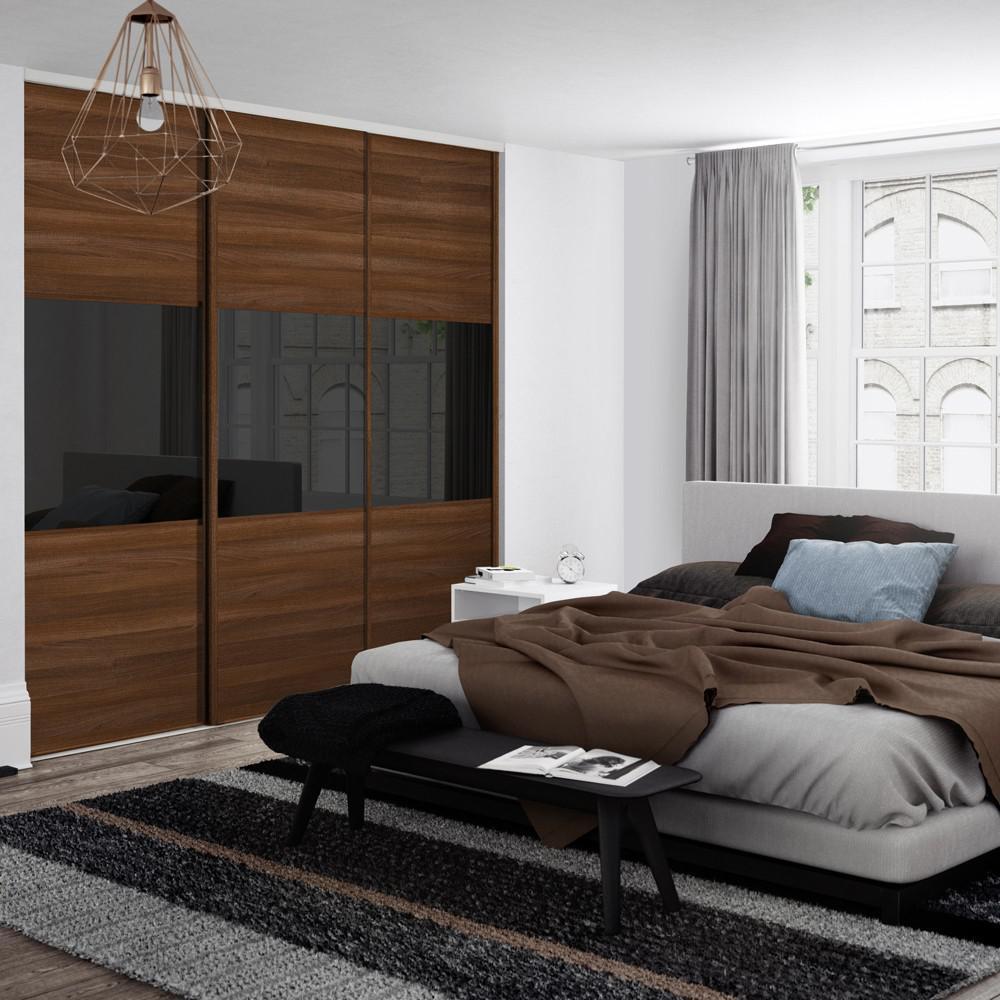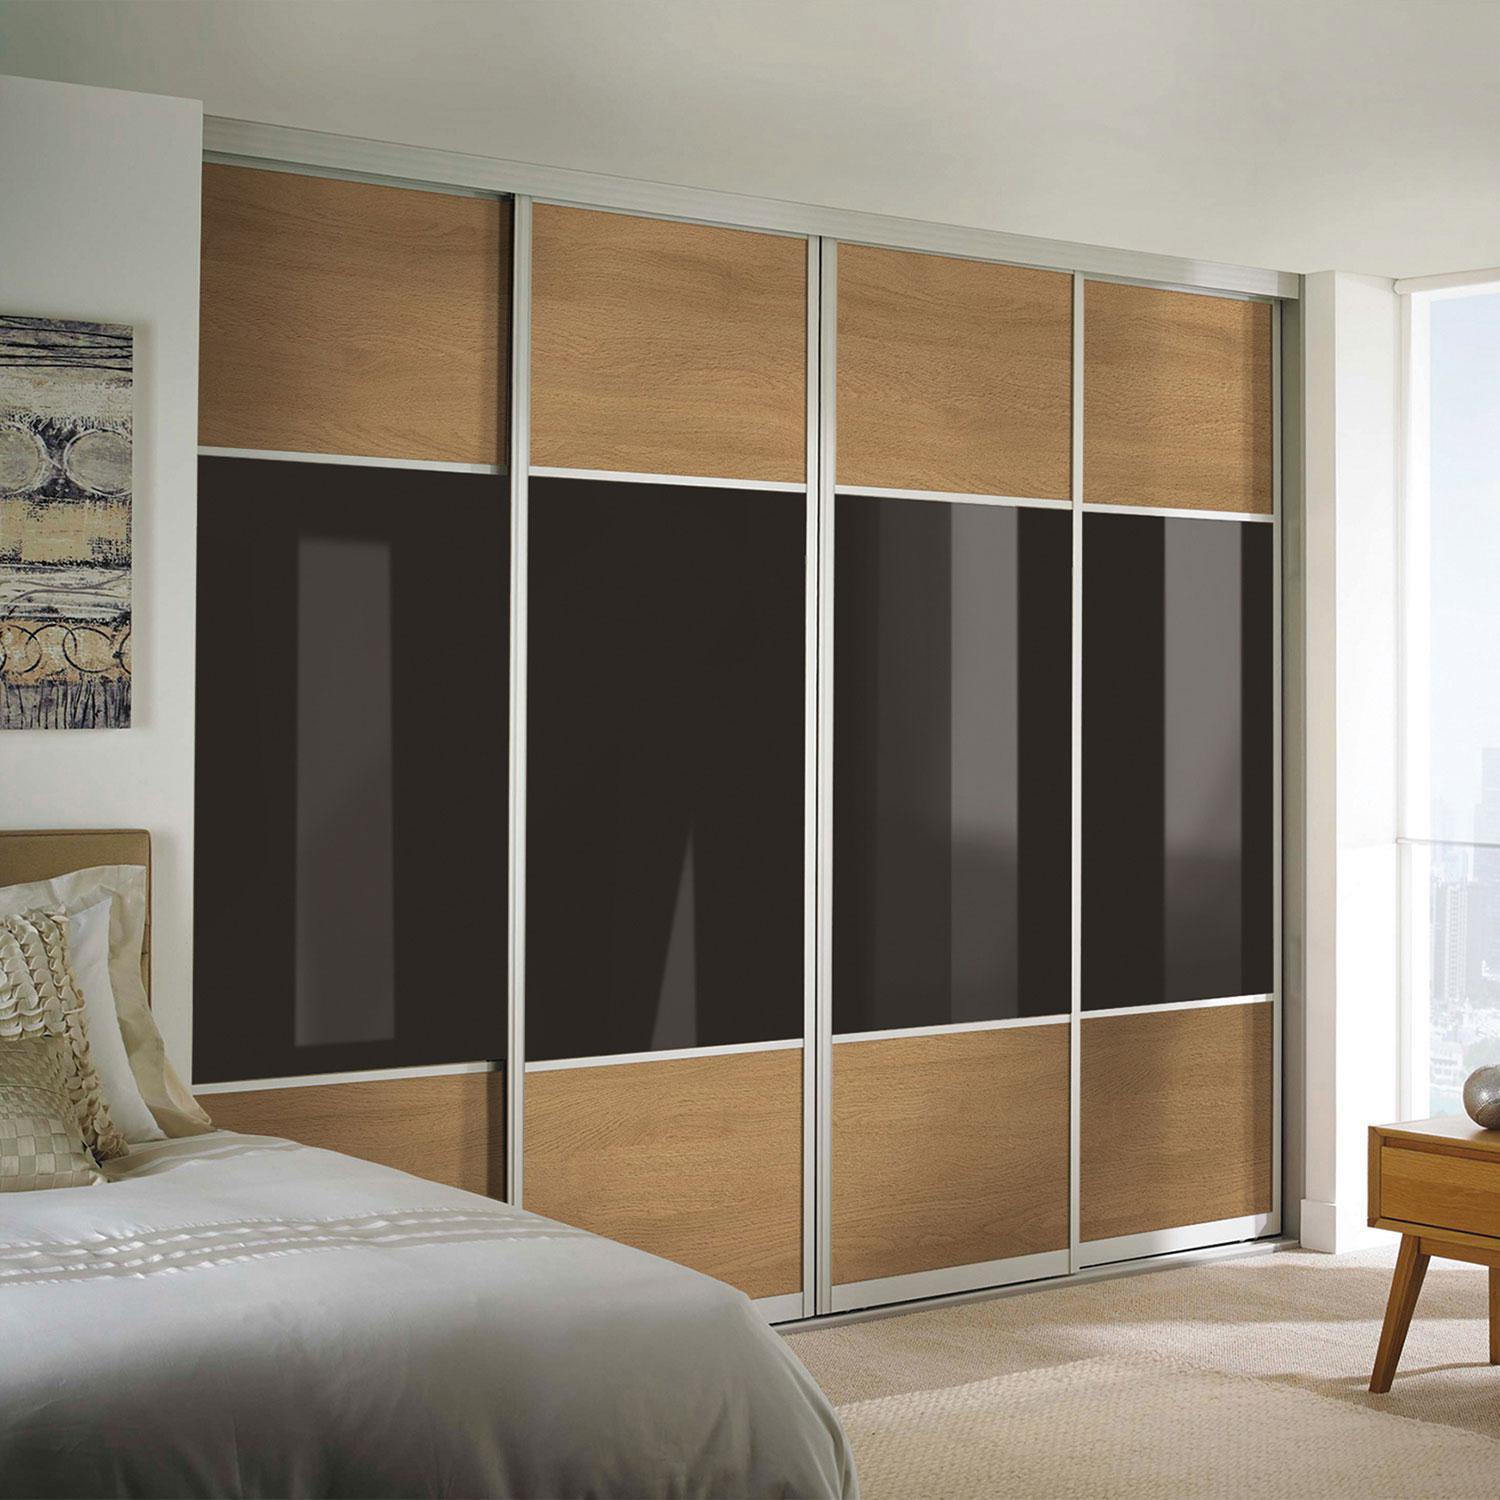The first image is the image on the left, the second image is the image on the right. For the images displayed, is the sentence "There are four black panels on the wooden closet in the image on the right." factually correct? Answer yes or no. Yes. 